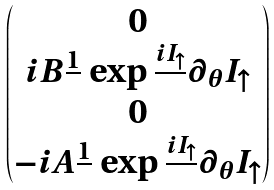Convert formula to latex. <formula><loc_0><loc_0><loc_500><loc_500>\begin{pmatrix} 0 \\ i B \frac { 1 } { } \exp \frac { i I _ { \uparrow } } { } \partial _ { \theta } I _ { \uparrow } \\ 0 \\ - i A \frac { 1 } { } \exp \frac { i I _ { \uparrow } } { } \partial _ { \theta } I _ { \uparrow } \end{pmatrix}</formula> 